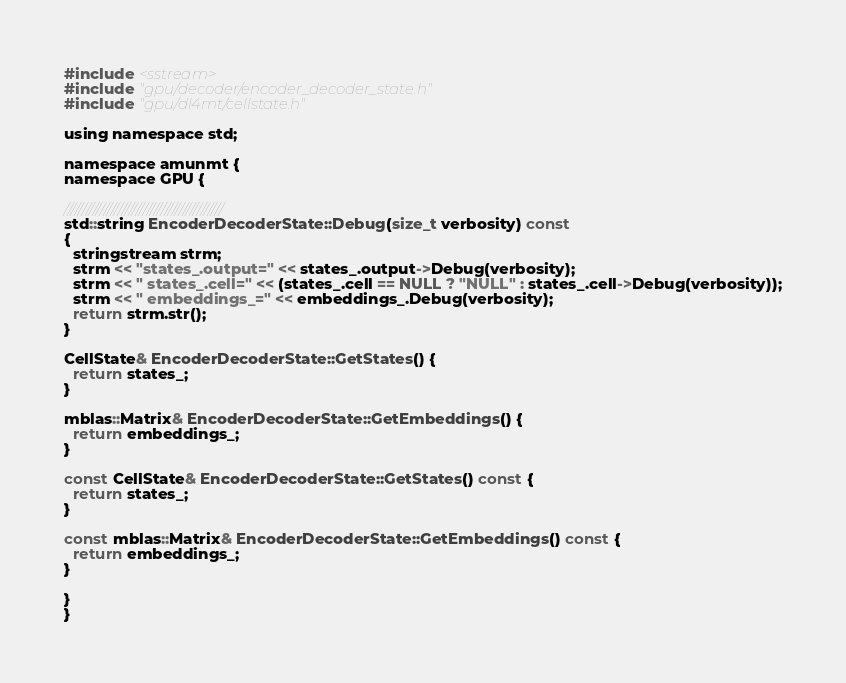<code> <loc_0><loc_0><loc_500><loc_500><_Cuda_>#include <sstream>
#include "gpu/decoder/encoder_decoder_state.h"
#include "gpu/dl4mt/cellstate.h"

using namespace std;

namespace amunmt {
namespace GPU {

////////////////////////////////////////////
std::string EncoderDecoderState::Debug(size_t verbosity) const
{
  stringstream strm;
  strm << "states_.output=" << states_.output->Debug(verbosity);
  strm << " states_.cell=" << (states_.cell == NULL ? "NULL" : states_.cell->Debug(verbosity));
  strm << " embeddings_=" << embeddings_.Debug(verbosity);
  return strm.str();
}

CellState& EncoderDecoderState::GetStates() {
  return states_;
}

mblas::Matrix& EncoderDecoderState::GetEmbeddings() {
  return embeddings_;
}

const CellState& EncoderDecoderState::GetStates() const {
  return states_;
}

const mblas::Matrix& EncoderDecoderState::GetEmbeddings() const {
  return embeddings_;
}

}
}

</code> 